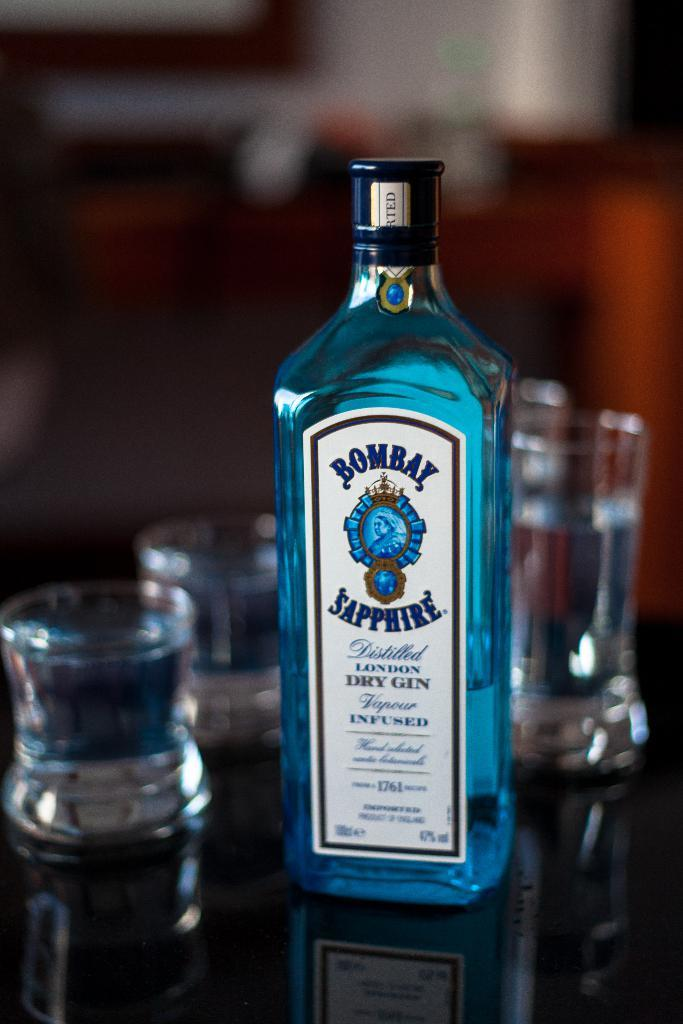Provide a one-sentence caption for the provided image. A group of glasses and a bottle of blue Bombay Sapphire. 